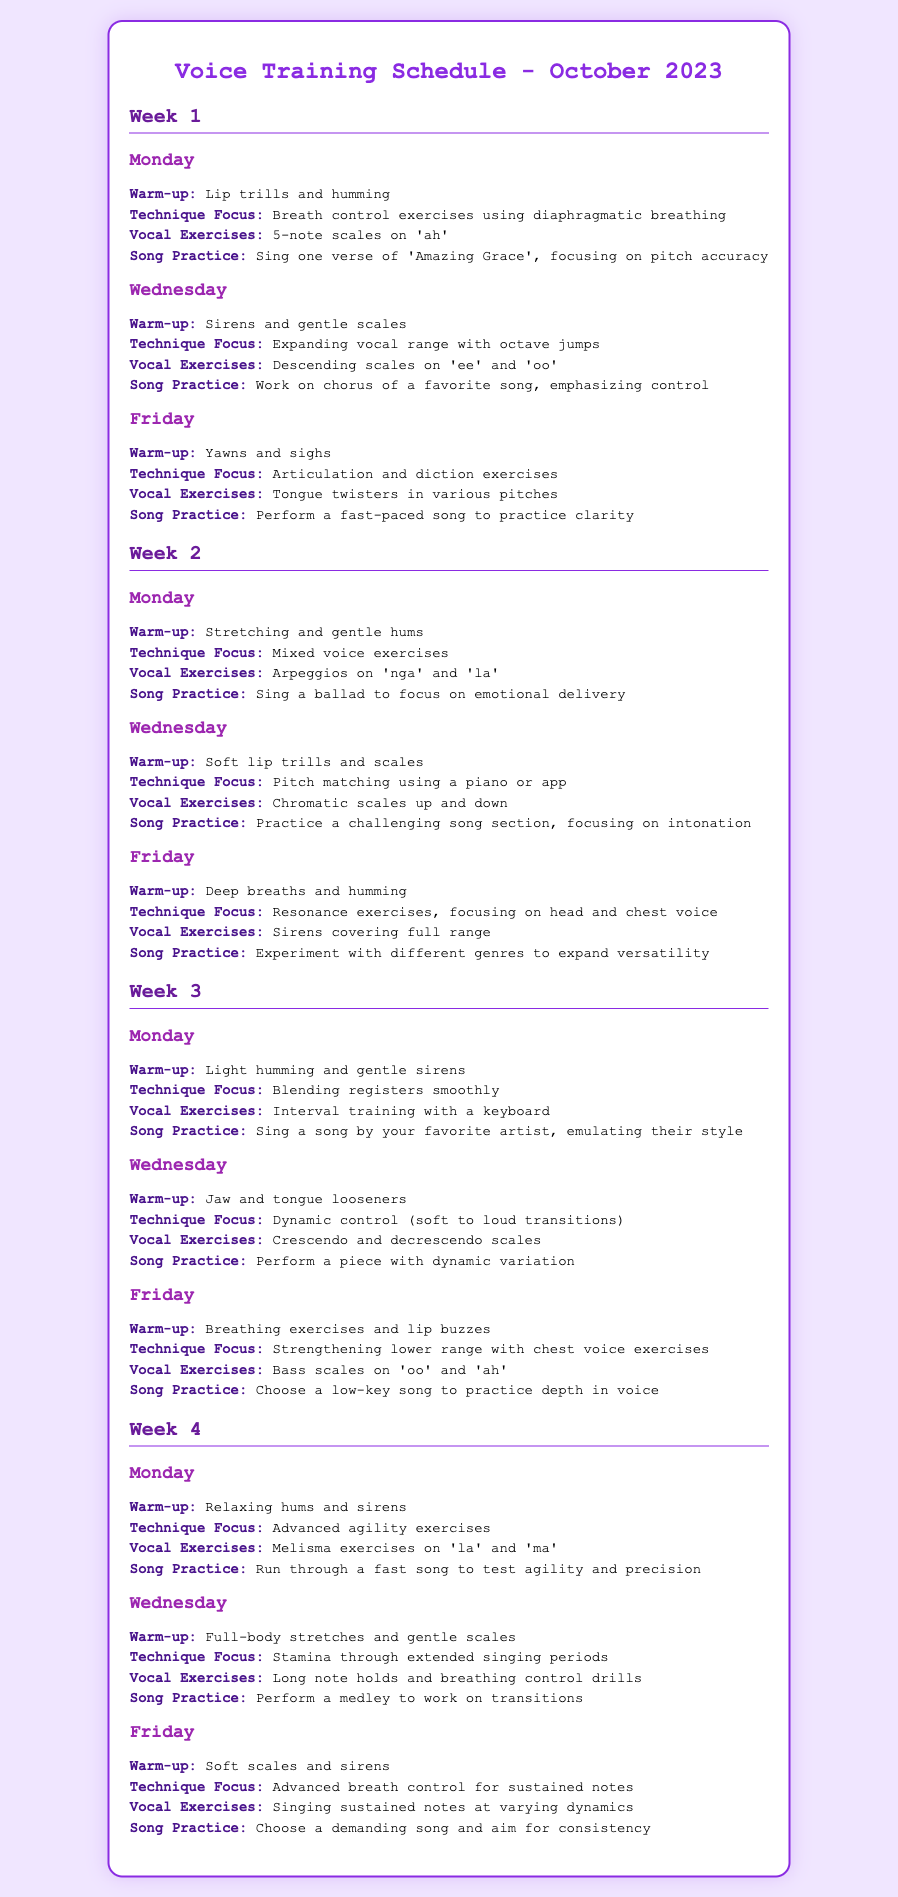what is the first vocal exercise listed for Week 1 Monday? The first vocal exercise for Week 1 Monday is lip trills and humming, which is part of the warm-up.
Answer: Lip trills and humming how many sessions are scheduled on Wednesday of Week 2? There are three sessions scheduled on Wednesday of Week 2: warm-up, technique focus, and vocal exercises, and song practice.
Answer: 4 what technique is focused on during Week 3 Friday? The technique focused on during Week 3 Friday is strengthening the lower range with chest voice exercises.
Answer: Strengthening lower range with chest voice exercises how many weeks are included in the voice training schedule for October 2023? The voice training schedule includes four weeks, as I've identified week numbers in the document.
Answer: 4 what type of song practice is suggested for the Friday session of Week 2? The song practice suggested for the Friday session of Week 2 is to experiment with different genres to expand versatility.
Answer: Experiment with different genres which day has a focus on advanced breath control for sustained notes? The focus on advanced breath control for sustained notes occurs on Friday in Week 4.
Answer: Friday Week 4 what is a key element practiced in the Monday session of Week 1? A key element practiced in the Monday session of Week 1 is breath control exercises using diaphragmatic breathing.
Answer: Breath control exercises using diaphragmatic breathing what vocal exercise is recommended for Week 3 Monday? The vocal exercise recommended for Week 3 Monday is interval training with a keyboard.
Answer: Interval training with a keyboard 